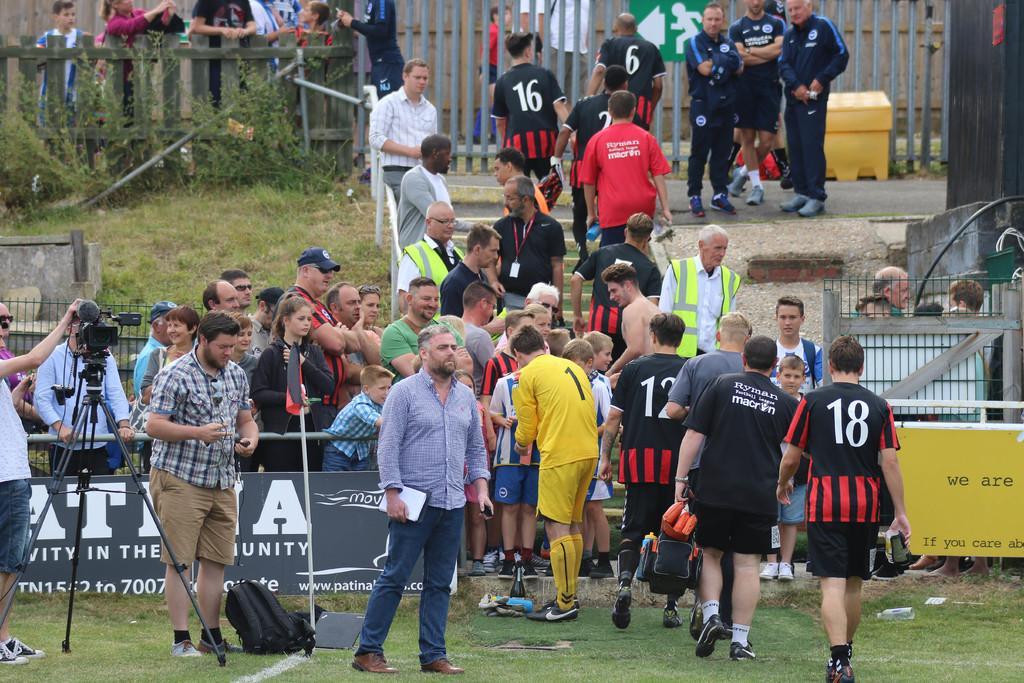Can you describe this image briefly? In this picture, there are people among them few people walking. We can see camera with tripod, bag, pole and objects on the grass and we can see fence. In the background we can see wooden fence, plants, yellow box, rods and boards. 